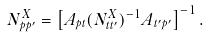Convert formula to latex. <formula><loc_0><loc_0><loc_500><loc_500>N _ { p p ^ { \prime } } ^ { X } = \left [ A _ { p t } ( { N _ { t t ^ { \prime } } ^ { X } } ) ^ { - 1 } A _ { t ^ { \prime } p ^ { \prime } } \right ] ^ { - 1 } .</formula> 